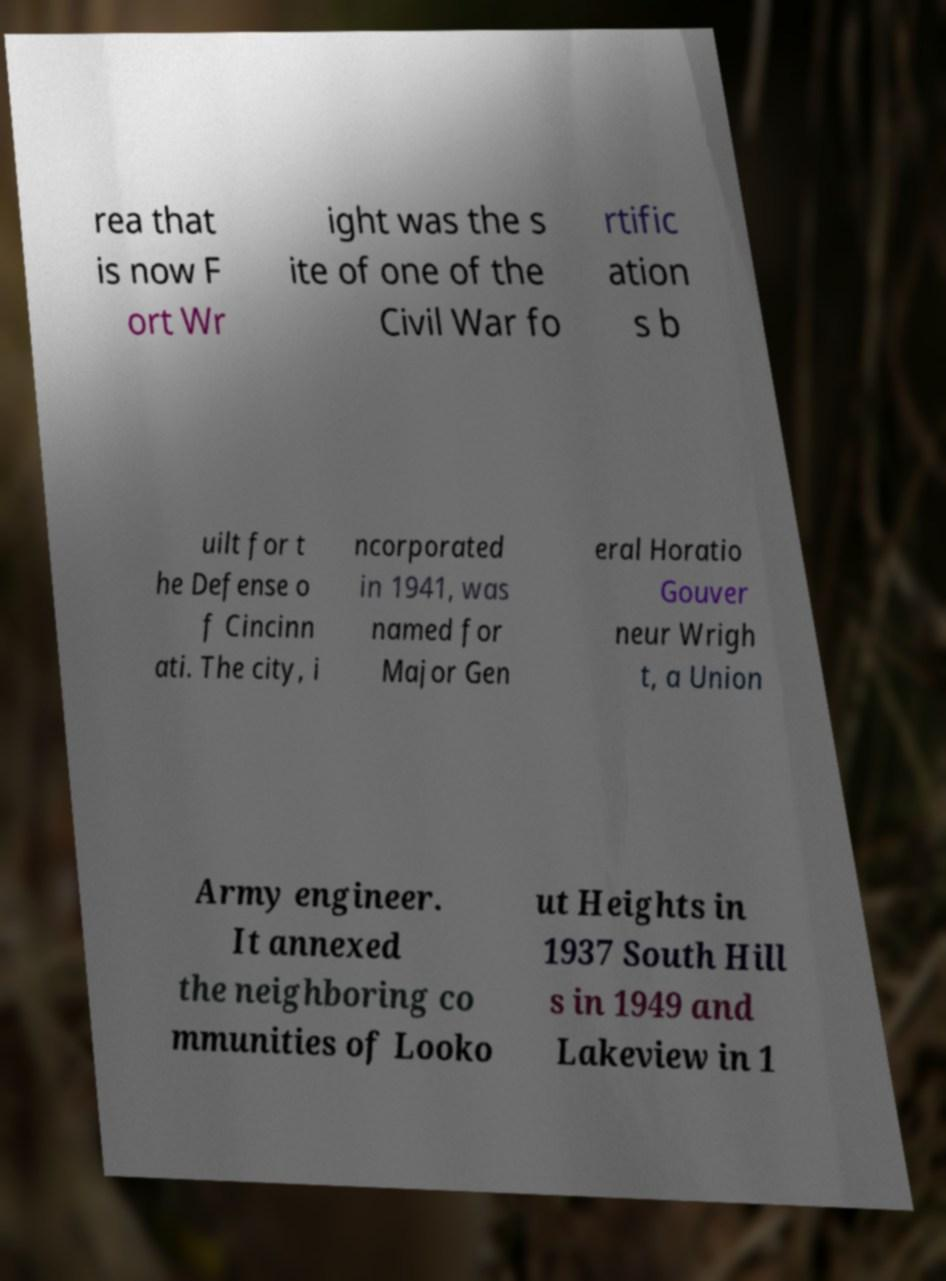Could you assist in decoding the text presented in this image and type it out clearly? rea that is now F ort Wr ight was the s ite of one of the Civil War fo rtific ation s b uilt for t he Defense o f Cincinn ati. The city, i ncorporated in 1941, was named for Major Gen eral Horatio Gouver neur Wrigh t, a Union Army engineer. It annexed the neighboring co mmunities of Looko ut Heights in 1937 South Hill s in 1949 and Lakeview in 1 